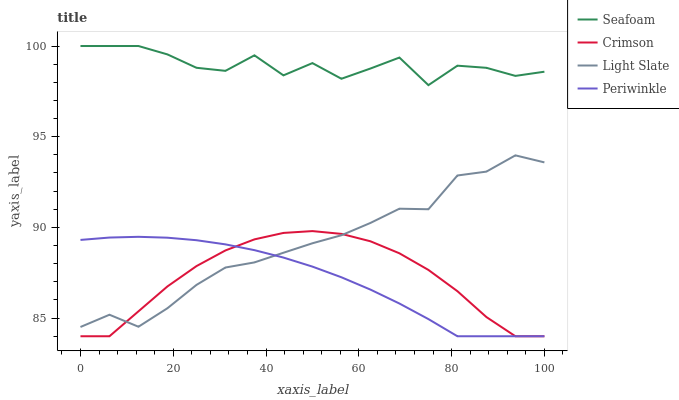Does Light Slate have the minimum area under the curve?
Answer yes or no. No. Does Light Slate have the maximum area under the curve?
Answer yes or no. No. Is Light Slate the smoothest?
Answer yes or no. No. Is Light Slate the roughest?
Answer yes or no. No. Does Light Slate have the lowest value?
Answer yes or no. No. Does Light Slate have the highest value?
Answer yes or no. No. Is Periwinkle less than Seafoam?
Answer yes or no. Yes. Is Seafoam greater than Crimson?
Answer yes or no. Yes. Does Periwinkle intersect Seafoam?
Answer yes or no. No. 